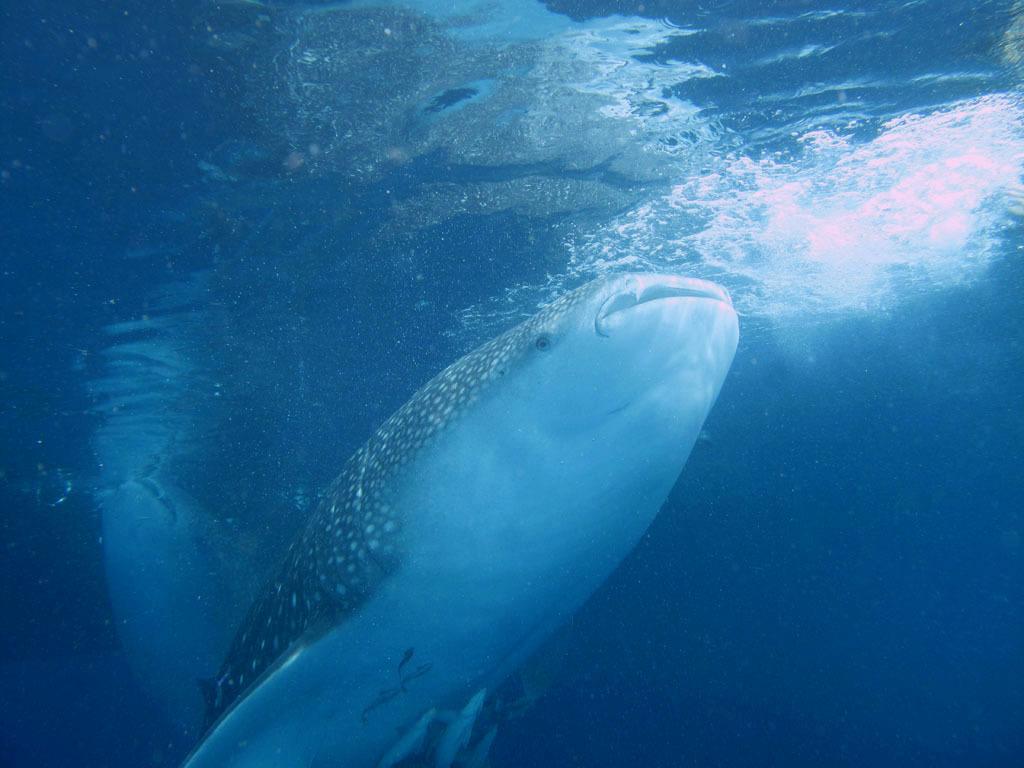Can you describe this image briefly? In this image there is a fish is in water. Bottom of image there are few small fishes in water. 